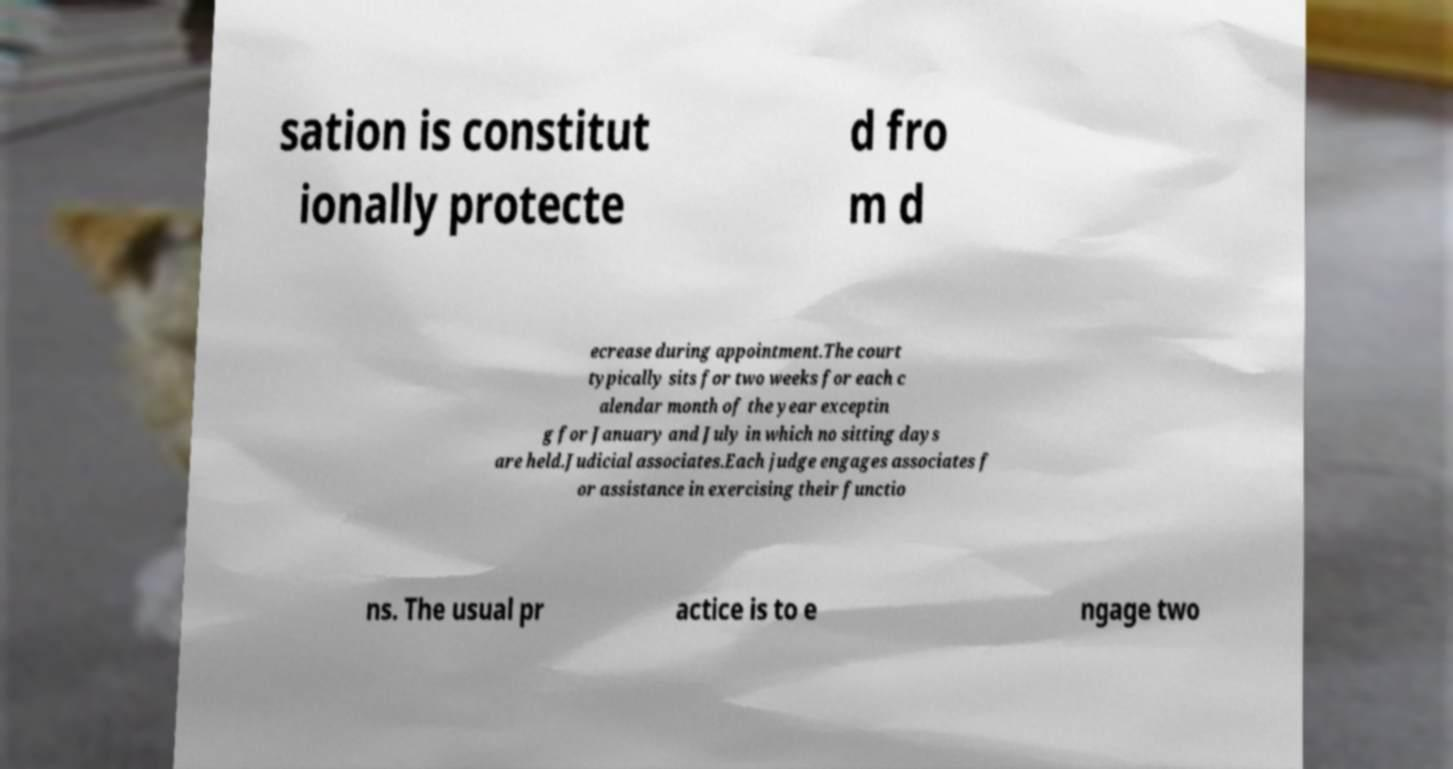Please read and relay the text visible in this image. What does it say? sation is constitut ionally protecte d fro m d ecrease during appointment.The court typically sits for two weeks for each c alendar month of the year exceptin g for January and July in which no sitting days are held.Judicial associates.Each judge engages associates f or assistance in exercising their functio ns. The usual pr actice is to e ngage two 